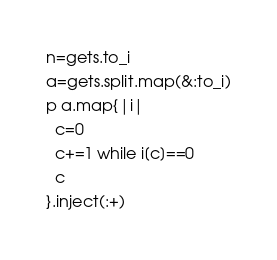Convert code to text. <code><loc_0><loc_0><loc_500><loc_500><_Ruby_>n=gets.to_i
a=gets.split.map(&:to_i)
p a.map{|i|
  c=0
  c+=1 while i[c]==0
  c
}.inject(:+)</code> 